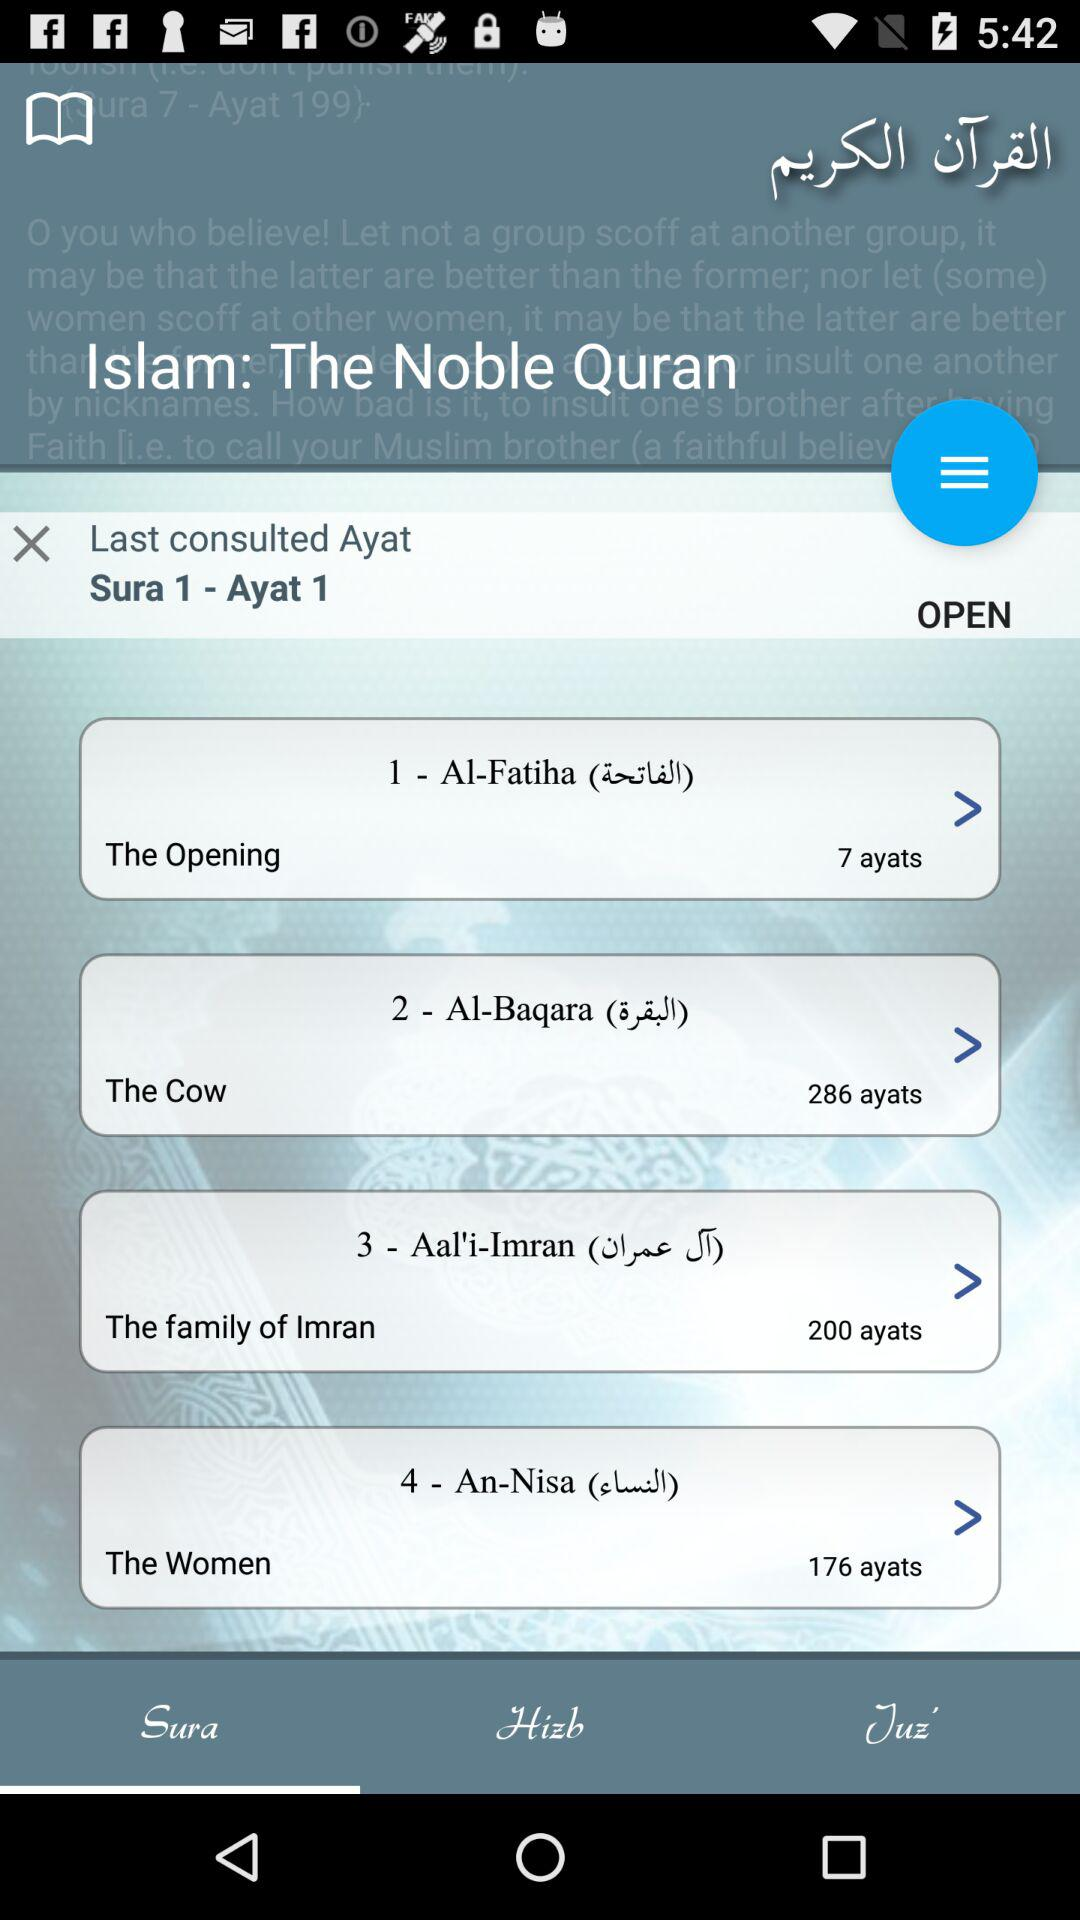How many more ayats are in Sura 3 than Sura 4?
Answer the question using a single word or phrase. 24 